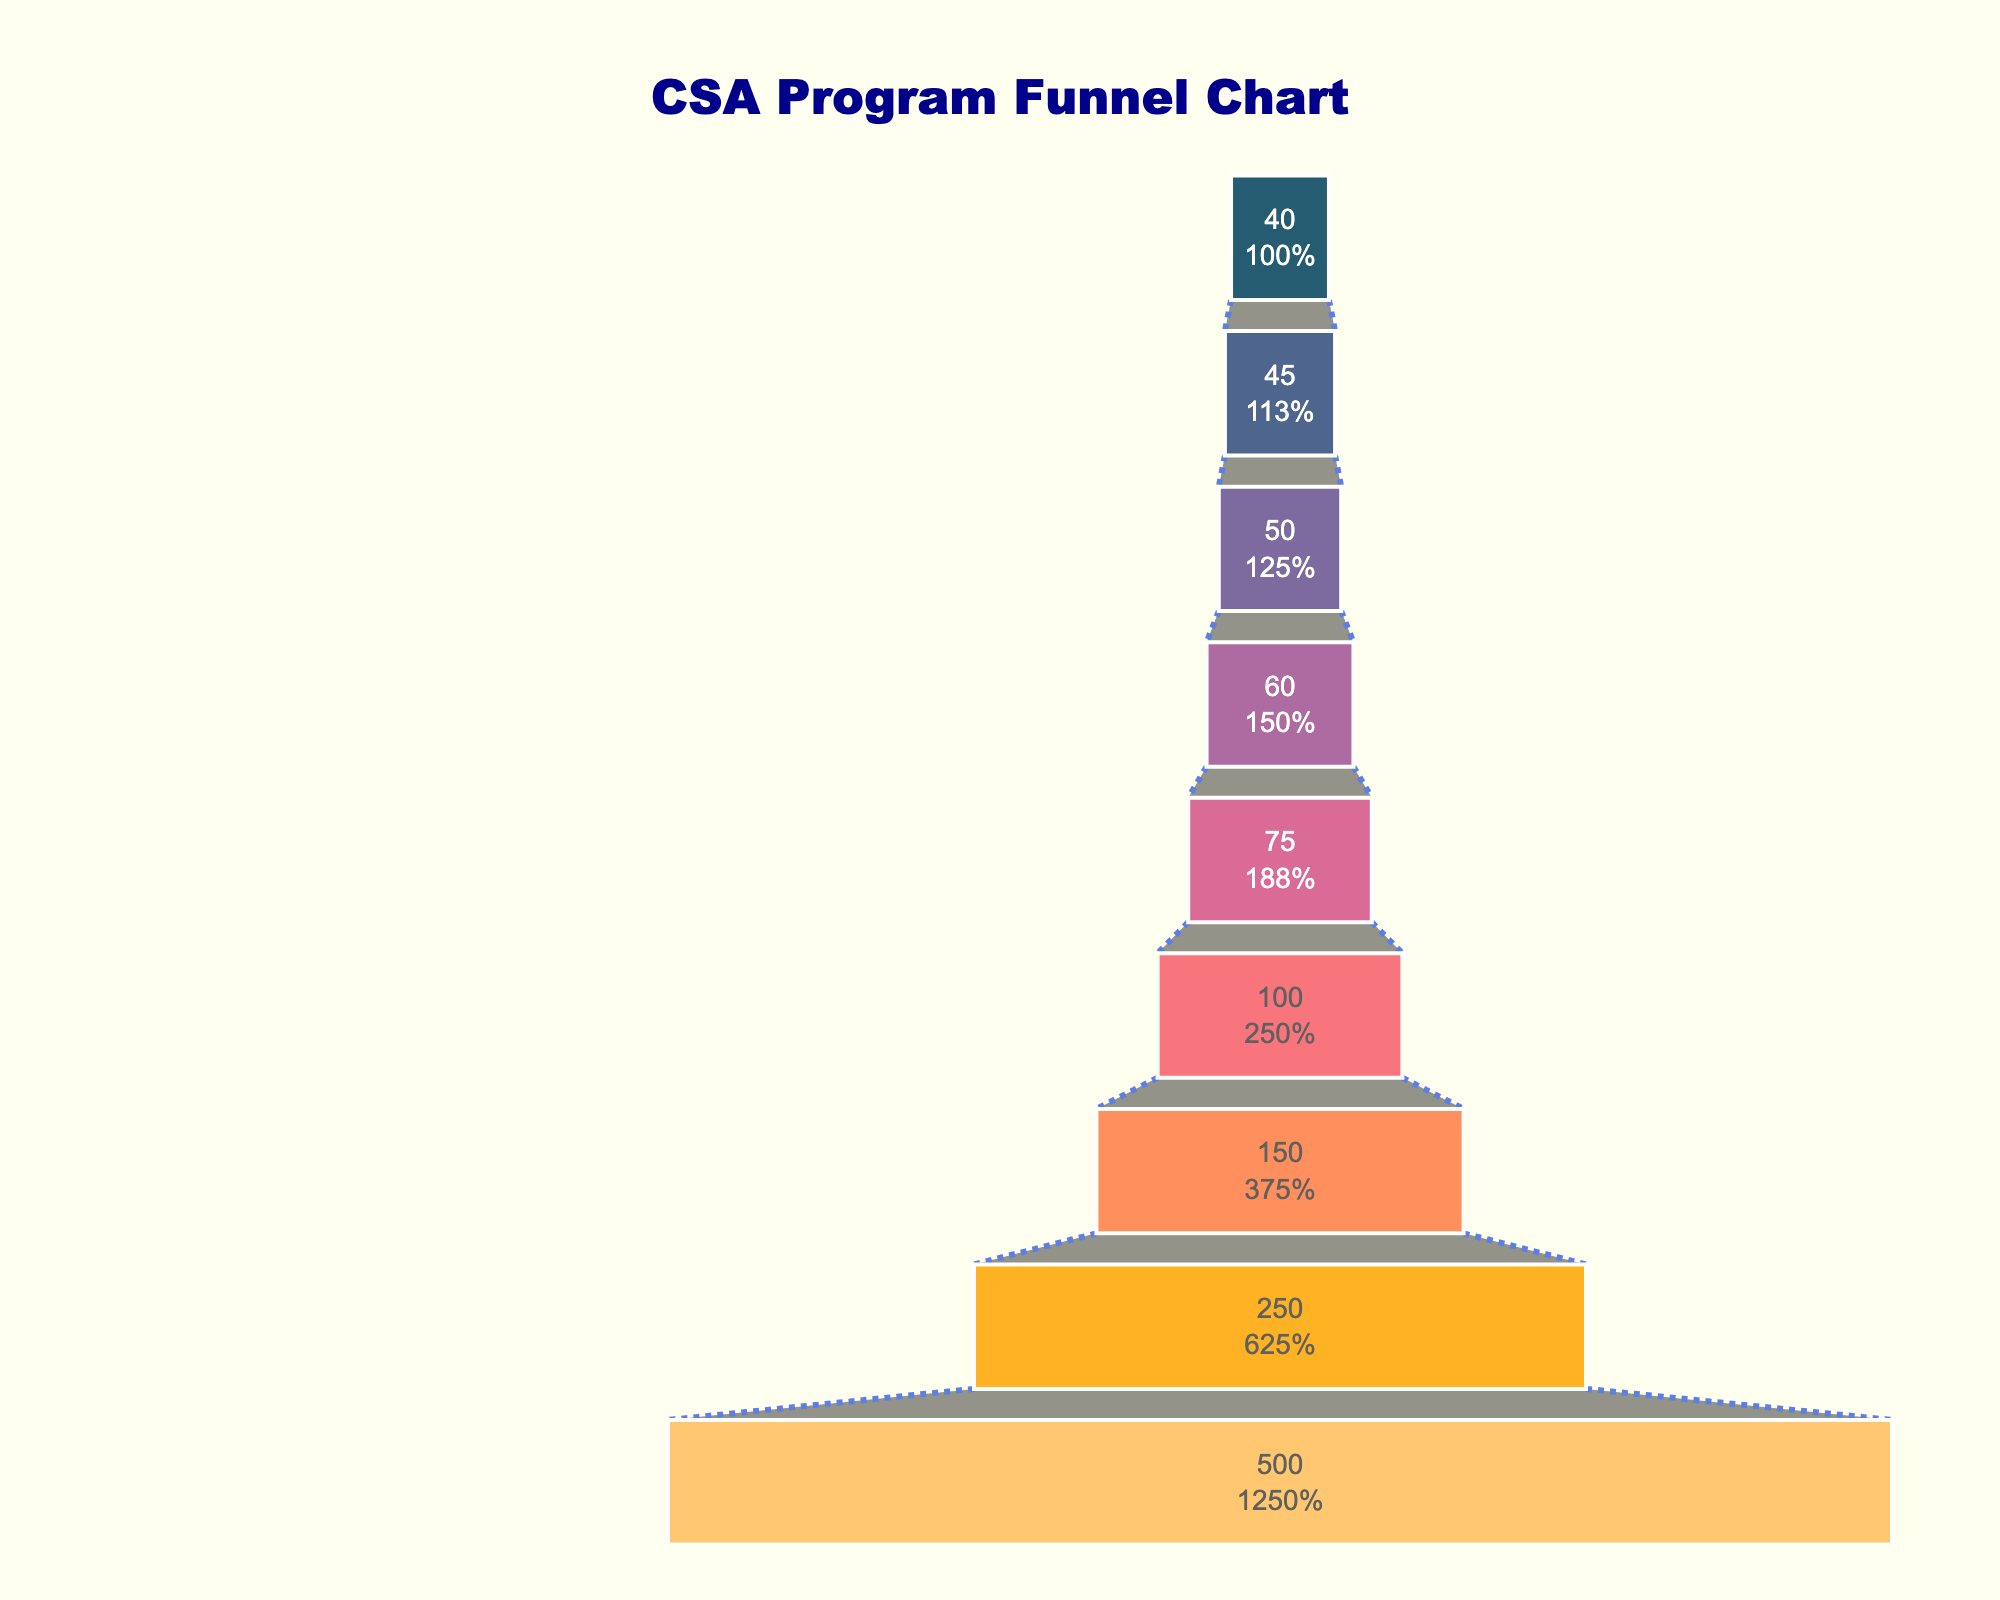What is the title of the funnel chart? The title of the chart is displayed at the top.
Answer: CSA Program Funnel Chart How many participants signed up for the CSA membership? Look at the section labeled “CSA membership sign-up” in the funnel and note the number of participants.
Answer: 75 Which stage had the highest number of participants? Identify the stage with the widest section at the top of the funnel.
Answer: Initial outreach to local community By how many participants did the number decrease from the initial outreach to the first harvest distribution? Subtract the number of participants at "First harvest distribution" from "Initial outreach to local community," i.e., 500 - 50.
Answer: 450 What is the percentage of participants that continued from the application process to the farm tours and meet-and-greets? Divide the number of participants at "Farm tours and meet-and-greets" by the number at "Application process" and then multiply by 100. (100/150)*100%
Answer: 66.67% Which stage experienced the largest drop in participants? Compare the differences between each consecutive stage by observing the lengths of each funnel section.
Answer: Initial outreach to local community to Information sessions for interested farmers What percentage of participants who attended the first harvest distribution participated in the end-of-season celebration and renewal? Divide the number of participants at "End-of-season celebration and renewal" by the number at "First harvest distribution," then multiply by 100. (40/50)*100%
Answer: 80% How many stages are there in the funnel chart? Count the distinct sections or stages listed in the funnel chart.
Answer: 9 What stage directly follows "Farm tours and meet-and-greets"? Look at the next stage listed below "Farm tours and meet-and-greets".
Answer: CSA membership sign-up Which two stages have fewer participants than the CSA membership sign-up stage? Compare participants in each stage and identify those with fewer participants than 75.
Answer: Pre-season planning meetings, End-of-season celebration and renewal 